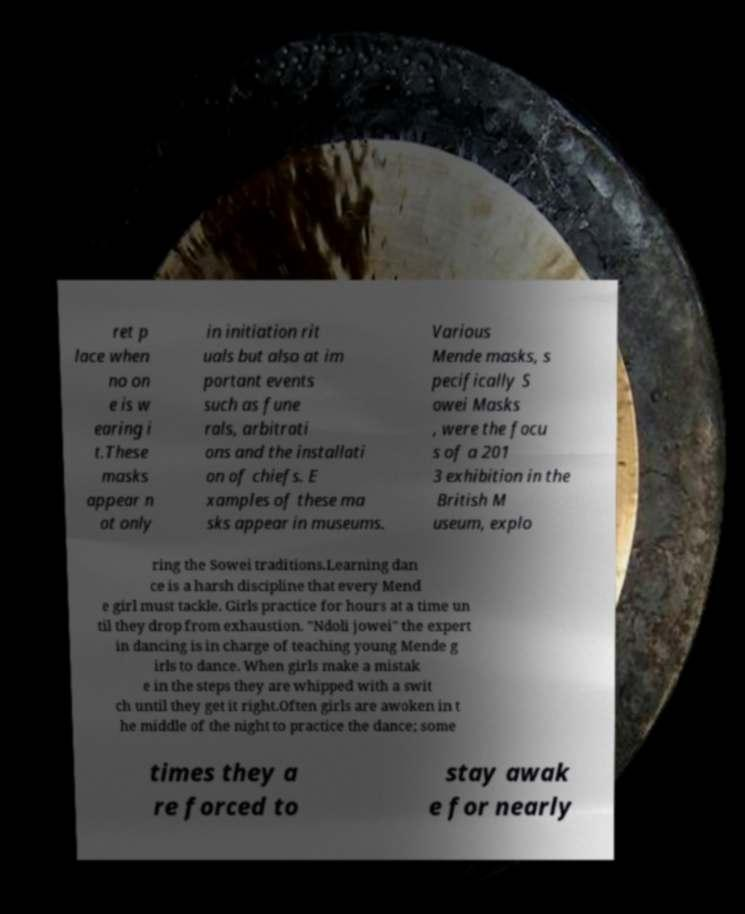For documentation purposes, I need the text within this image transcribed. Could you provide that? ret p lace when no on e is w earing i t.These masks appear n ot only in initiation rit uals but also at im portant events such as fune rals, arbitrati ons and the installati on of chiefs. E xamples of these ma sks appear in museums. Various Mende masks, s pecifically S owei Masks , were the focu s of a 201 3 exhibition in the British M useum, explo ring the Sowei traditions.Learning dan ce is a harsh discipline that every Mend e girl must tackle. Girls practice for hours at a time un til they drop from exhaustion. "Ndoli jowei" the expert in dancing is in charge of teaching young Mende g irls to dance. When girls make a mistak e in the steps they are whipped with a swit ch until they get it right.Often girls are awoken in t he middle of the night to practice the dance; some times they a re forced to stay awak e for nearly 